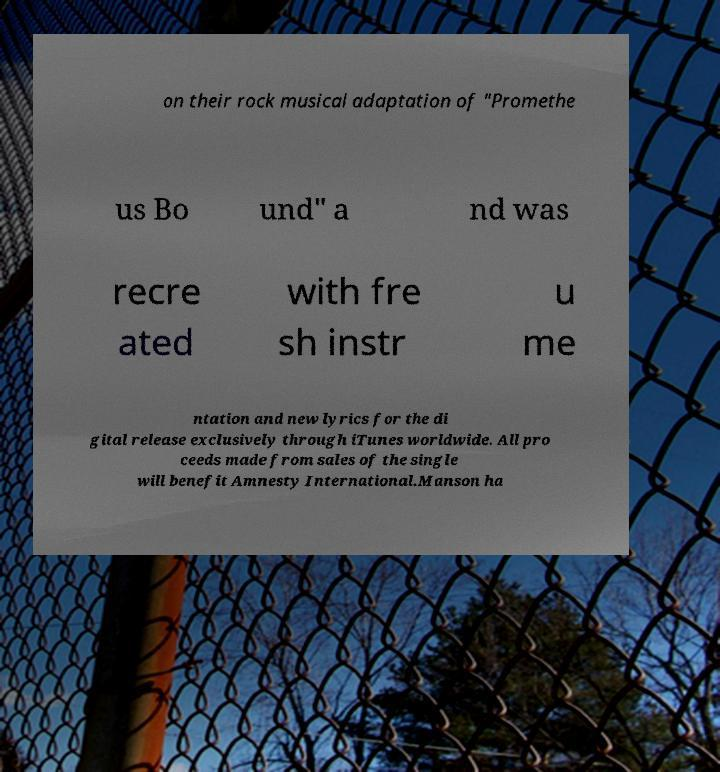There's text embedded in this image that I need extracted. Can you transcribe it verbatim? on their rock musical adaptation of "Promethe us Bo und" a nd was recre ated with fre sh instr u me ntation and new lyrics for the di gital release exclusively through iTunes worldwide. All pro ceeds made from sales of the single will benefit Amnesty International.Manson ha 